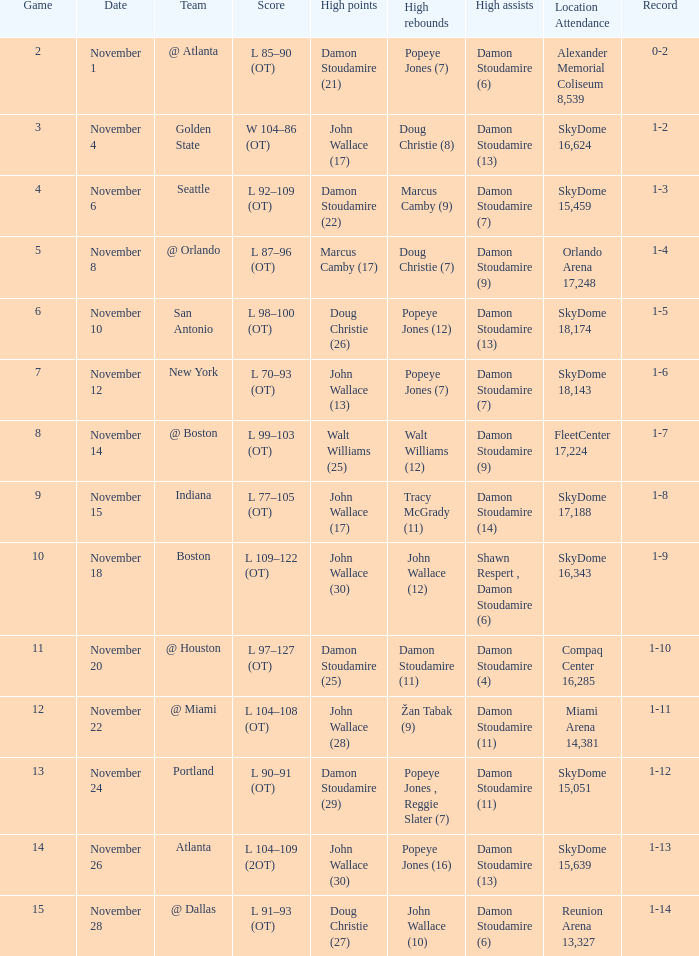How did the game against san antonio end in terms of points? L 98–100 (OT). 